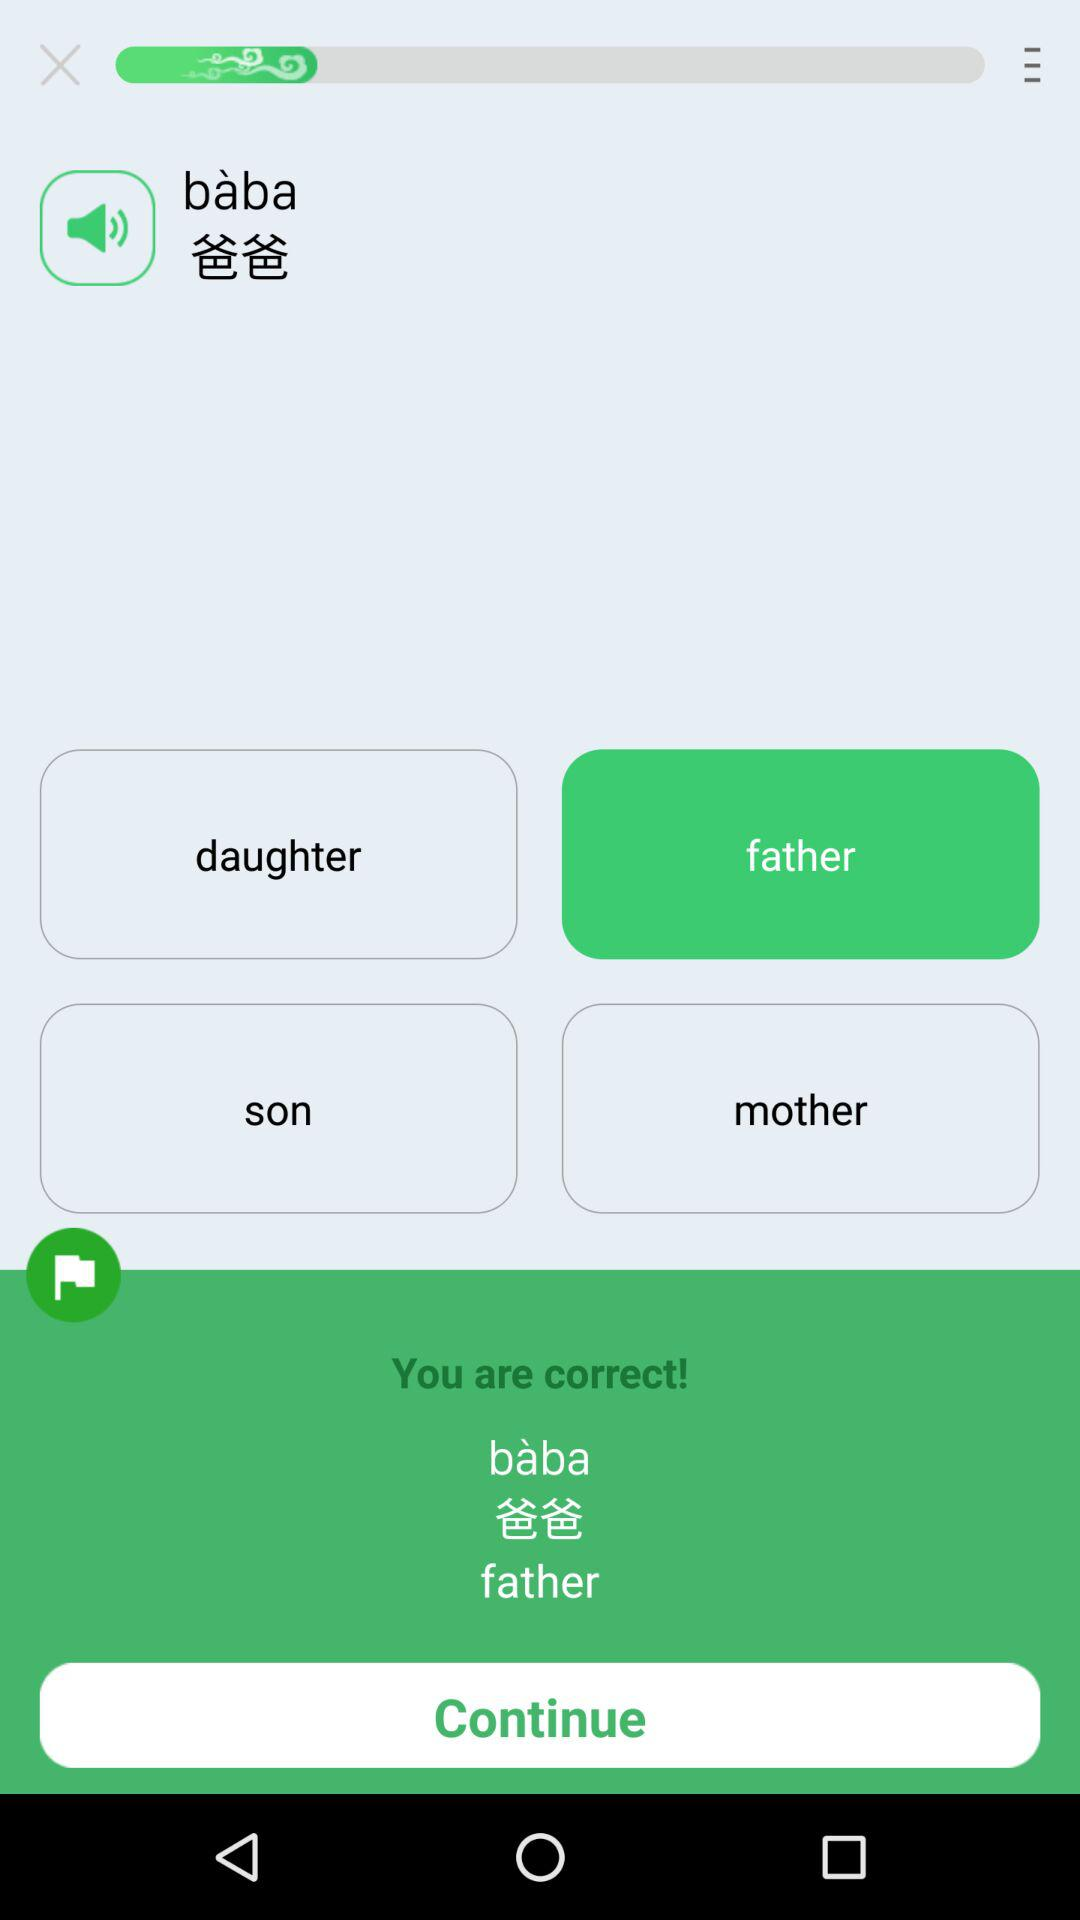Which option is selected? The selected option is "father". 